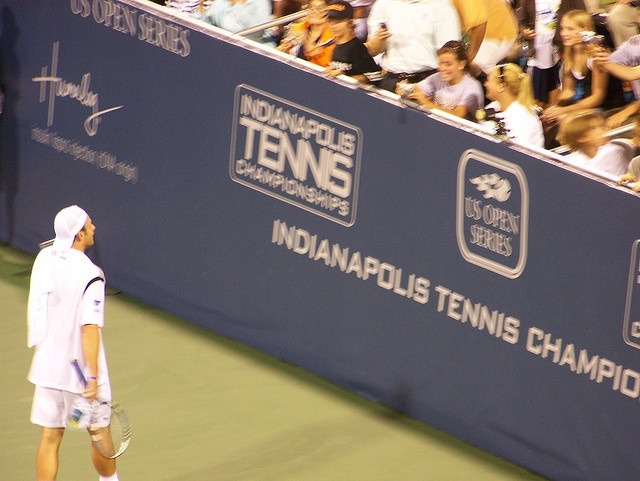Describe the objects in this image and their specific colors. I can see people in black, white, orange, and tan tones, people in black, ivory, and tan tones, people in black, lightgray, and maroon tones, people in black, white, orange, olive, and tan tones, and people in black, orange, lightgray, tan, and maroon tones in this image. 